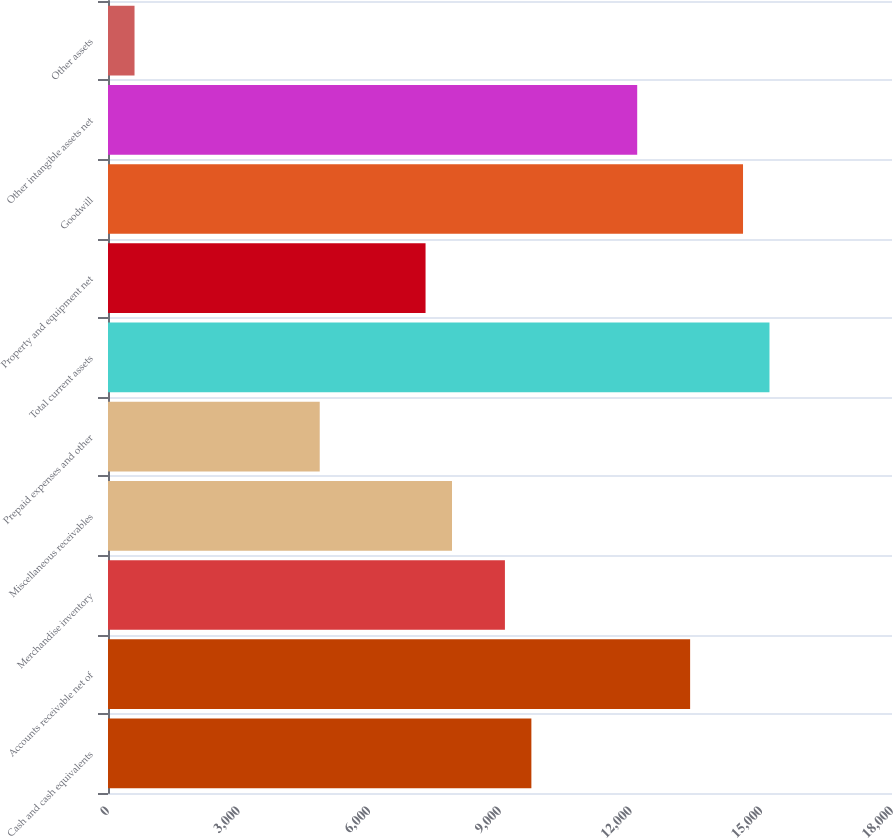Convert chart. <chart><loc_0><loc_0><loc_500><loc_500><bar_chart><fcel>Cash and cash equivalents<fcel>Accounts receivable net of<fcel>Merchandise inventory<fcel>Miscellaneous receivables<fcel>Prepaid expenses and other<fcel>Total current assets<fcel>Property and equipment net<fcel>Goodwill<fcel>Other intangible assets net<fcel>Other assets<nl><fcel>9720.42<fcel>13364.9<fcel>9113<fcel>7898.16<fcel>4861.06<fcel>15187.2<fcel>7290.74<fcel>14579.8<fcel>12150.1<fcel>609.12<nl></chart> 